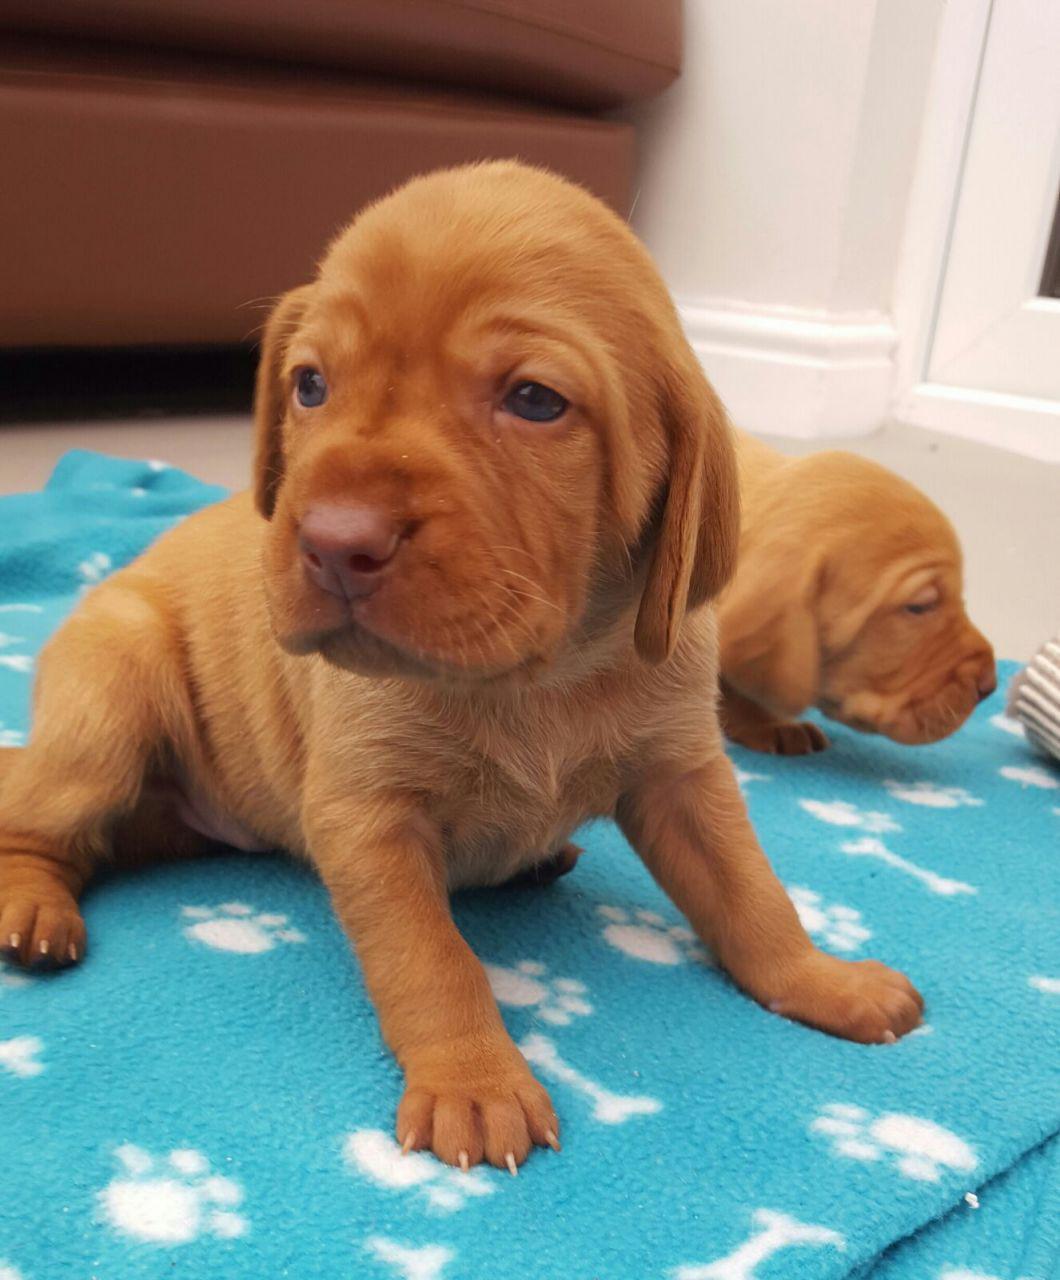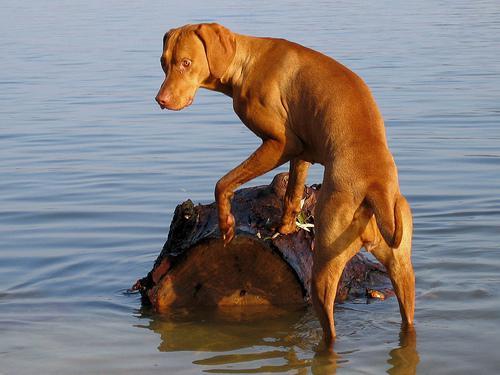The first image is the image on the left, the second image is the image on the right. Analyze the images presented: Is the assertion "A boy and a dog face toward each other in one image, and two dogs are in a natural body of water in the other image." valid? Answer yes or no. No. The first image is the image on the left, the second image is the image on the right. For the images displayed, is the sentence "The left image contains exactly two dogs." factually correct? Answer yes or no. Yes. 